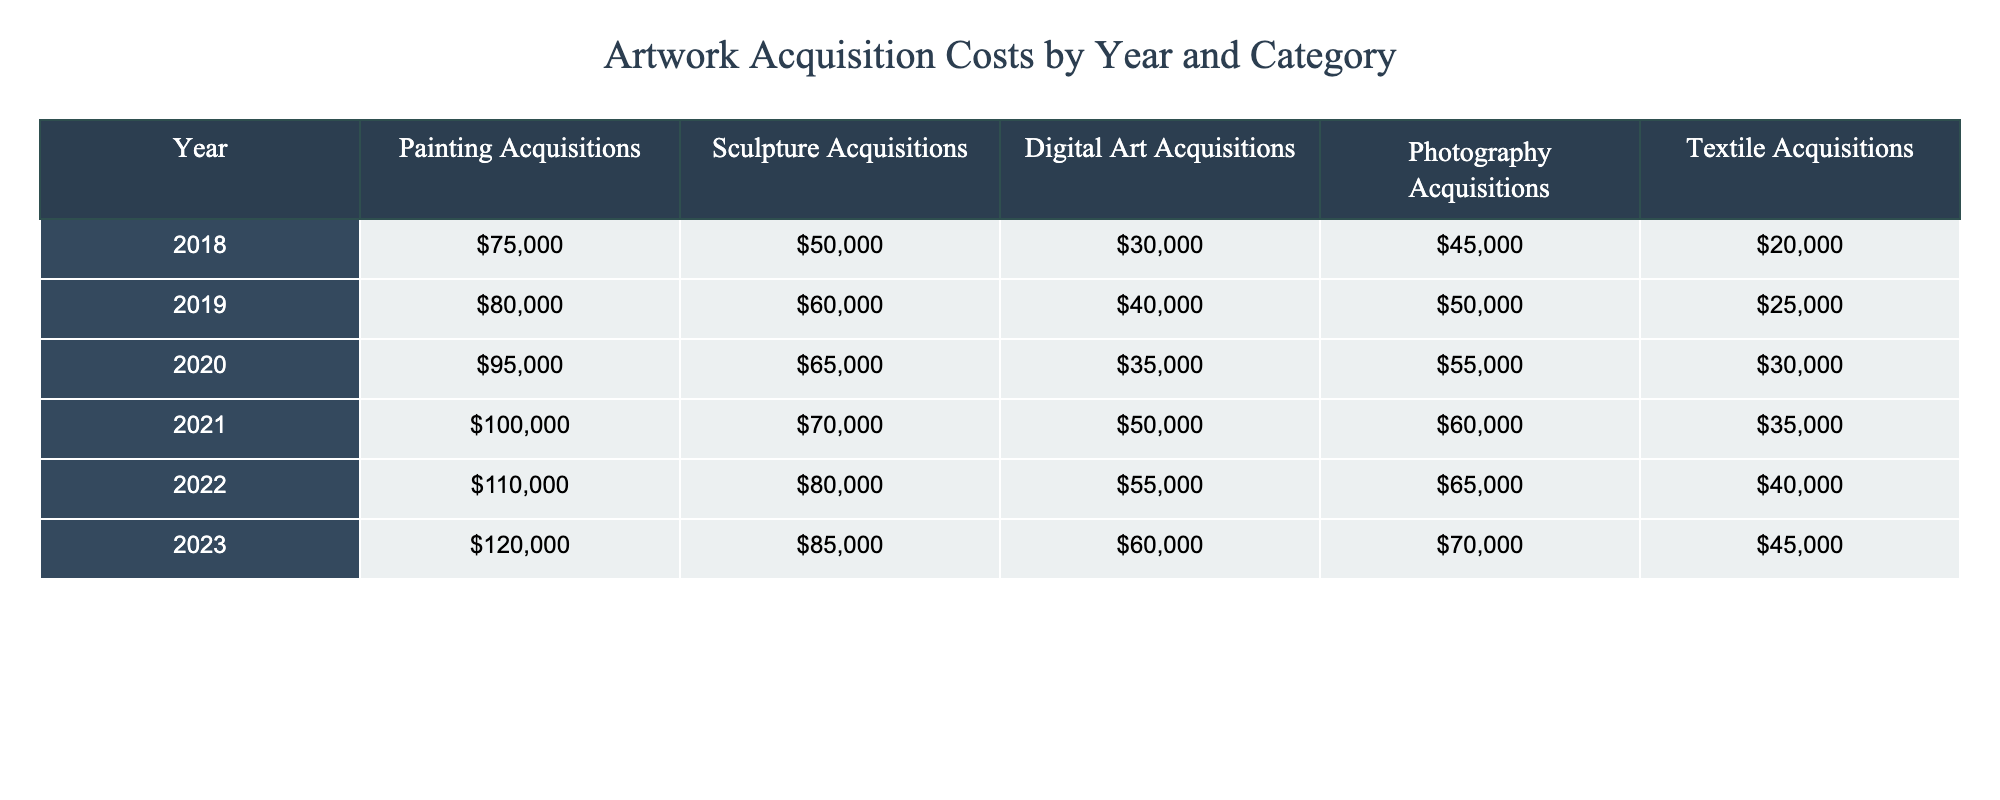What was the total spending on photography acquisitions in 2021? The photography acquisition cost for 2021 is listed in the table as 60,000.
Answer: 60,000 Which year had the highest expenditure on sculpture acquisitions? The values for sculpture acquisitions are highest in 2023 with 85,000 compared to other years.
Answer: 2023 What is the average cost of digital art acquisitions over the years? Adding the digital art acquisition costs for each year: (30,000 + 40,000 + 35,000 + 50,000 + 55,000 + 60,000 = 270,000). Dividing by the 6 years gives an average of 270,000 / 6 = 45,000.
Answer: 45,000 Did the total spending on all categories increase from 2018 to 2023? The total spending can be calculated for both years: in 2018, it is 75,000 + 50,000 + 30,000 + 45,000 + 20,000 = 220,000; in 2023, it is 120,000 + 85,000 + 60,000 + 70,000 + 45,000 = 380,000. Since 380,000 is greater than 220,000, the answer is yes.
Answer: Yes What was the difference in total spending on painting acquisitions between 2020 and 2022? The painting acquisition costs for 2020 and 2022 are 95,000 and 110,000, respectively. The difference is 110,000 - 95,000 = 15,000.
Answer: 15,000 In which category was the increase in acquisitions from 2019 to 2020 the largest? The increase for each category from 2019 to 2020 is: Painting: 95,000 - 80,000 = 15,000; Sculpture: 65,000 - 60,000 = 5,000; Digital Art: 35,000 - 40,000 = -5,000 (decrease); Photography: 55,000 - 50,000 = 5,000; Textile: 30,000 - 25,000 = 5,000. The largest increase is in Painting.
Answer: Painting What is the total amount spent on textile acquisitions from 2018 to 2023? The total for textile acquisitions is: 20,000 + 25,000 + 30,000 + 35,000 + 40,000 + 45,000 = 195,000.
Answer: 195,000 Was the expenditure on sculpture acquisitions consistently higher than that on textile acquisitions from 2018 to 2023? Comparing each year's values: Sculpture 2018 (50,000) vs Textile (20,000) - Yes; Sculpture 2019 (60,000) vs Textile (25,000) - Yes; Sculpture 2020 (65,000) vs Textile (30,000) - Yes; Sculpture 2021 (70,000) vs Textile (35,000) - Yes; Sculpture 2022 (80,000) vs Textile (40,000) - Yes; Sculpture 2023 (85,000) vs Textile (45,000) - Yes. The expenditures in sculpture were consistently higher.
Answer: Yes What was the rate of increase in painting acquisitions from 2021 to 2023? The painting acquisitions were 100,000 in 2021 and 120,000 in 2023. The increase is 120,000 - 100,000 = 20,000 which is a rate of increase of (20,000 / 100,000) * 100 = 20%.
Answer: 20% 